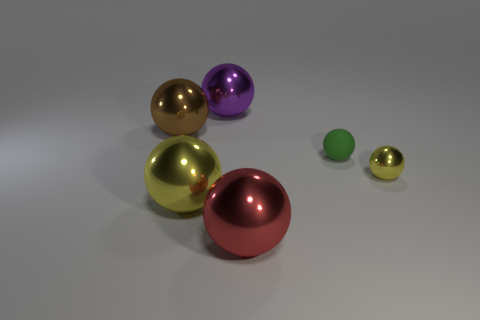Subtract 2 spheres. How many spheres are left? 4 Subtract all purple balls. How many balls are left? 5 Subtract all red spheres. How many spheres are left? 5 Subtract all blue balls. Subtract all gray cubes. How many balls are left? 6 Add 1 big brown objects. How many objects exist? 7 Subtract 0 blue cubes. How many objects are left? 6 Subtract all red objects. Subtract all big gray matte objects. How many objects are left? 5 Add 1 red shiny spheres. How many red shiny spheres are left? 2 Add 6 tiny rubber things. How many tiny rubber things exist? 7 